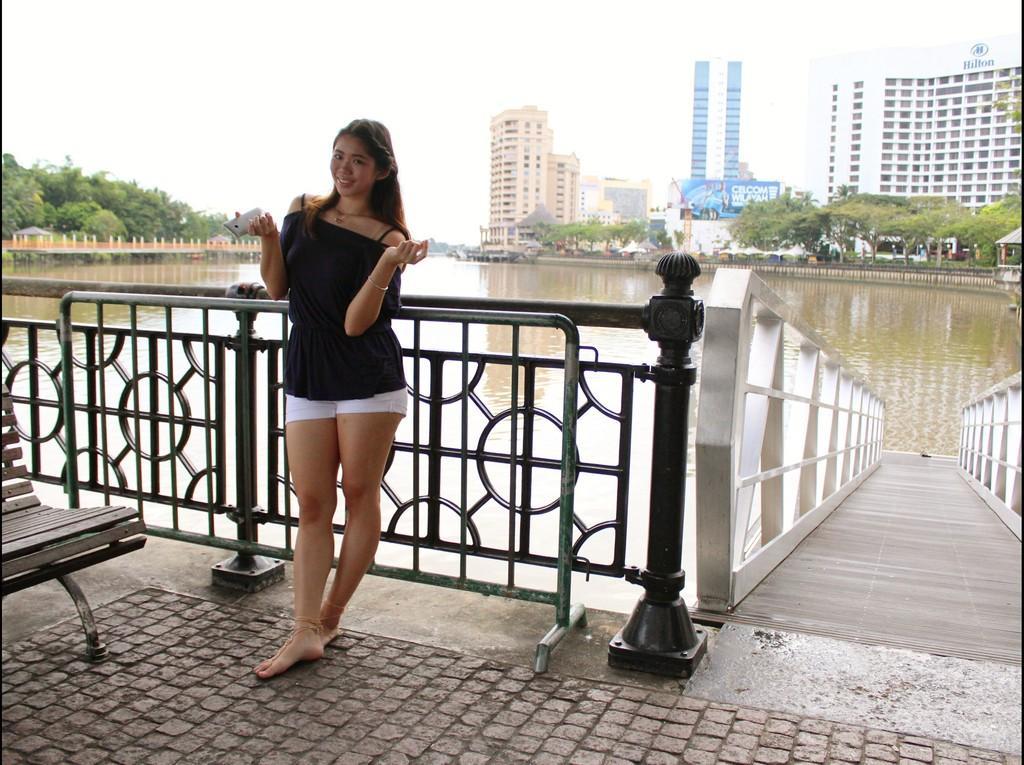How would you summarize this image in a sentence or two? In this image we can see women wearing black dress is holding a mobile phone and standing near the steel railing. Here we can see the wooden bench, we can see water, bridge, trees, buildings and the sky in the background. 